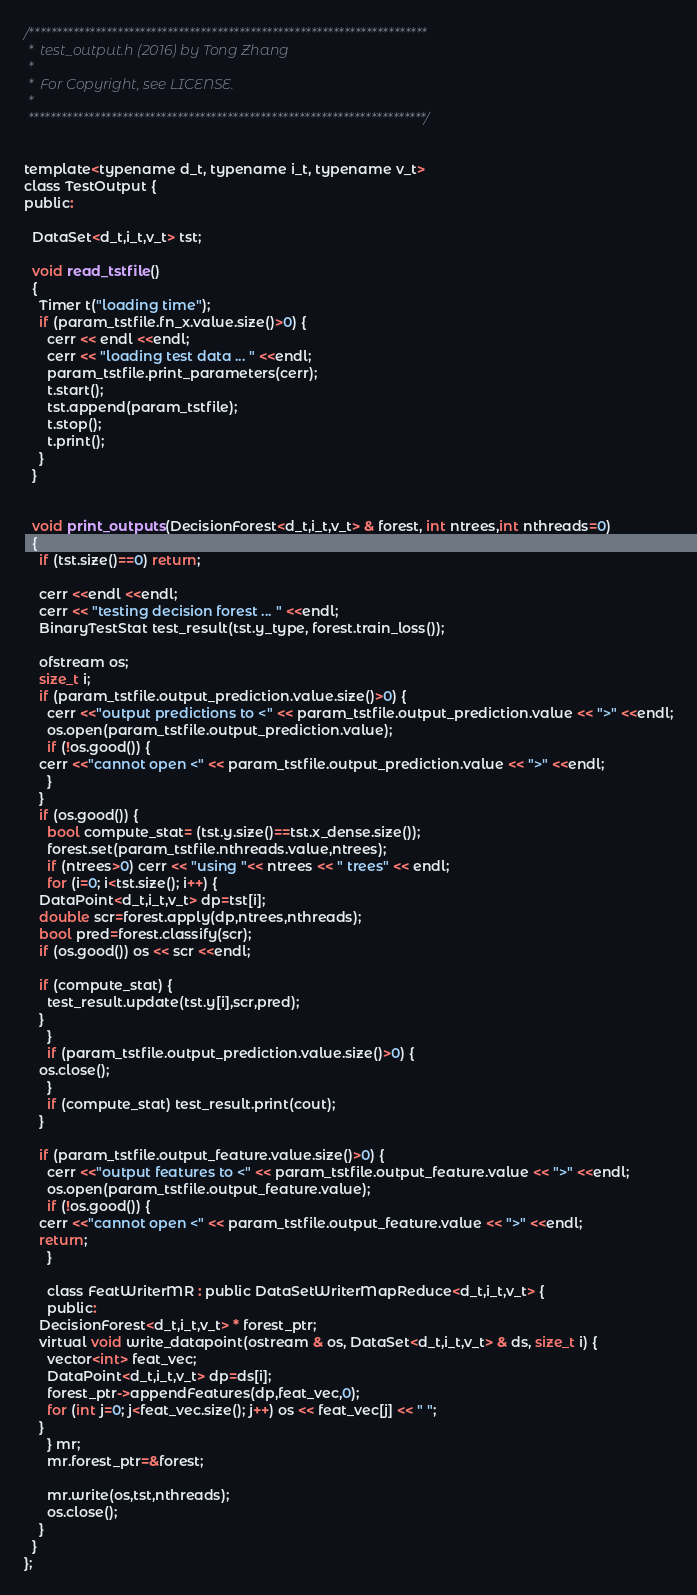<code> <loc_0><loc_0><loc_500><loc_500><_C_>/************************************************************************
 *  test_output.h (2016) by Tong Zhang
 *  
 *  For Copyright, see LICENSE.
 *  
 ************************************************************************/


template<typename d_t, typename i_t, typename v_t>
class TestOutput {
public:

  DataSet<d_t,i_t,v_t> tst;
  
  void read_tstfile()
  {
    Timer t("loading time");
    if (param_tstfile.fn_x.value.size()>0) {
      cerr << endl <<endl;
      cerr << "loading test data ... " <<endl;
      param_tstfile.print_parameters(cerr);
      t.start();
      tst.append(param_tstfile);
      t.stop();
      t.print();
    }
  }
  

  void print_outputs(DecisionForest<d_t,i_t,v_t> & forest, int ntrees,int nthreads=0)
  {
    if (tst.size()==0) return;
    
    cerr <<endl <<endl;
    cerr << "testing decision forest ... " <<endl;
    BinaryTestStat test_result(tst.y_type, forest.train_loss());

    ofstream os;
    size_t i;
    if (param_tstfile.output_prediction.value.size()>0) {
      cerr <<"output predictions to <" << param_tstfile.output_prediction.value << ">" <<endl;
      os.open(param_tstfile.output_prediction.value);
      if (!os.good()) {
	cerr <<"cannot open <" << param_tstfile.output_prediction.value << ">" <<endl;
      }
    }
    if (os.good()) {
      bool compute_stat= (tst.y.size()==tst.x_dense.size());
      forest.set(param_tstfile.nthreads.value,ntrees);
      if (ntrees>0) cerr << "using "<< ntrees << " trees" << endl;
      for (i=0; i<tst.size(); i++) {
	DataPoint<d_t,i_t,v_t> dp=tst[i];
	double scr=forest.apply(dp,ntrees,nthreads);
	bool pred=forest.classify(scr);
	if (os.good()) os << scr <<endl;
	
	if (compute_stat) {
	  test_result.update(tst.y[i],scr,pred);
	}
      }
      if (param_tstfile.output_prediction.value.size()>0) {
	os.close();
      }
      if (compute_stat) test_result.print(cout);
    }
    
    if (param_tstfile.output_feature.value.size()>0) {
      cerr <<"output features to <" << param_tstfile.output_feature.value << ">" <<endl;
      os.open(param_tstfile.output_feature.value);
      if (!os.good()) {
	cerr <<"cannot open <" << param_tstfile.output_feature.value << ">" <<endl;
	return;
      }

      class FeatWriterMR : public DataSetWriterMapReduce<d_t,i_t,v_t> {
      public:
	DecisionForest<d_t,i_t,v_t> * forest_ptr;
	virtual void write_datapoint(ostream & os, DataSet<d_t,i_t,v_t> & ds, size_t i) {
	  vector<int> feat_vec;
	  DataPoint<d_t,i_t,v_t> dp=ds[i];
	  forest_ptr->appendFeatures(dp,feat_vec,0);
	  for (int j=0; j<feat_vec.size(); j++) os << feat_vec[j] << " ";
	}
      } mr;
      mr.forest_ptr=&forest;
      
      mr.write(os,tst,nthreads);
      os.close();
    }
  }
};
</code> 